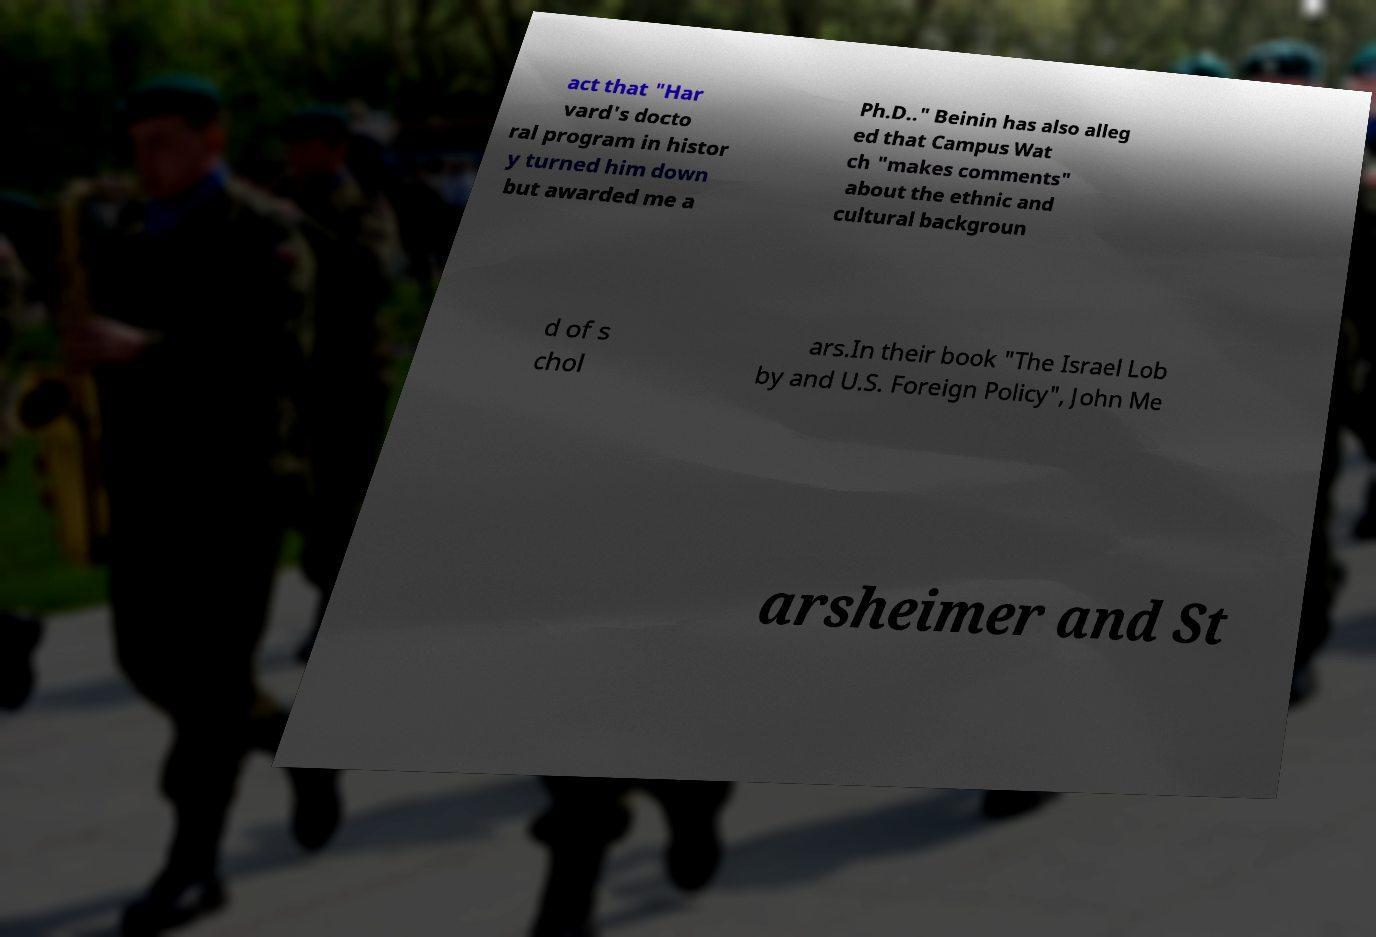There's text embedded in this image that I need extracted. Can you transcribe it verbatim? act that "Har vard's docto ral program in histor y turned him down but awarded me a Ph.D.." Beinin has also alleg ed that Campus Wat ch "makes comments" about the ethnic and cultural backgroun d of s chol ars.In their book "The Israel Lob by and U.S. Foreign Policy", John Me arsheimer and St 